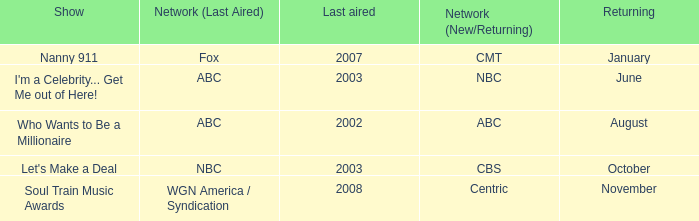Can you give me this table as a dict? {'header': ['Show', 'Network (Last Aired)', 'Last aired', 'Network (New/Returning)', 'Returning'], 'rows': [['Nanny 911', 'Fox', '2007', 'CMT', 'January'], ["I'm a Celebrity... Get Me out of Here!", 'ABC', '2003', 'NBC', 'June'], ['Who Wants to Be a Millionaire', 'ABC', '2002', 'ABC', 'August'], ["Let's Make a Deal", 'NBC', '2003', 'CBS', 'October'], ['Soul Train Music Awards', 'WGN America / Syndication', '2008', 'Centric', 'November']]} When did a program last broadcasted in 2002 come back? August. 